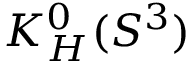<formula> <loc_0><loc_0><loc_500><loc_500>K _ { H } ^ { 0 } ( S ^ { 3 } )</formula> 